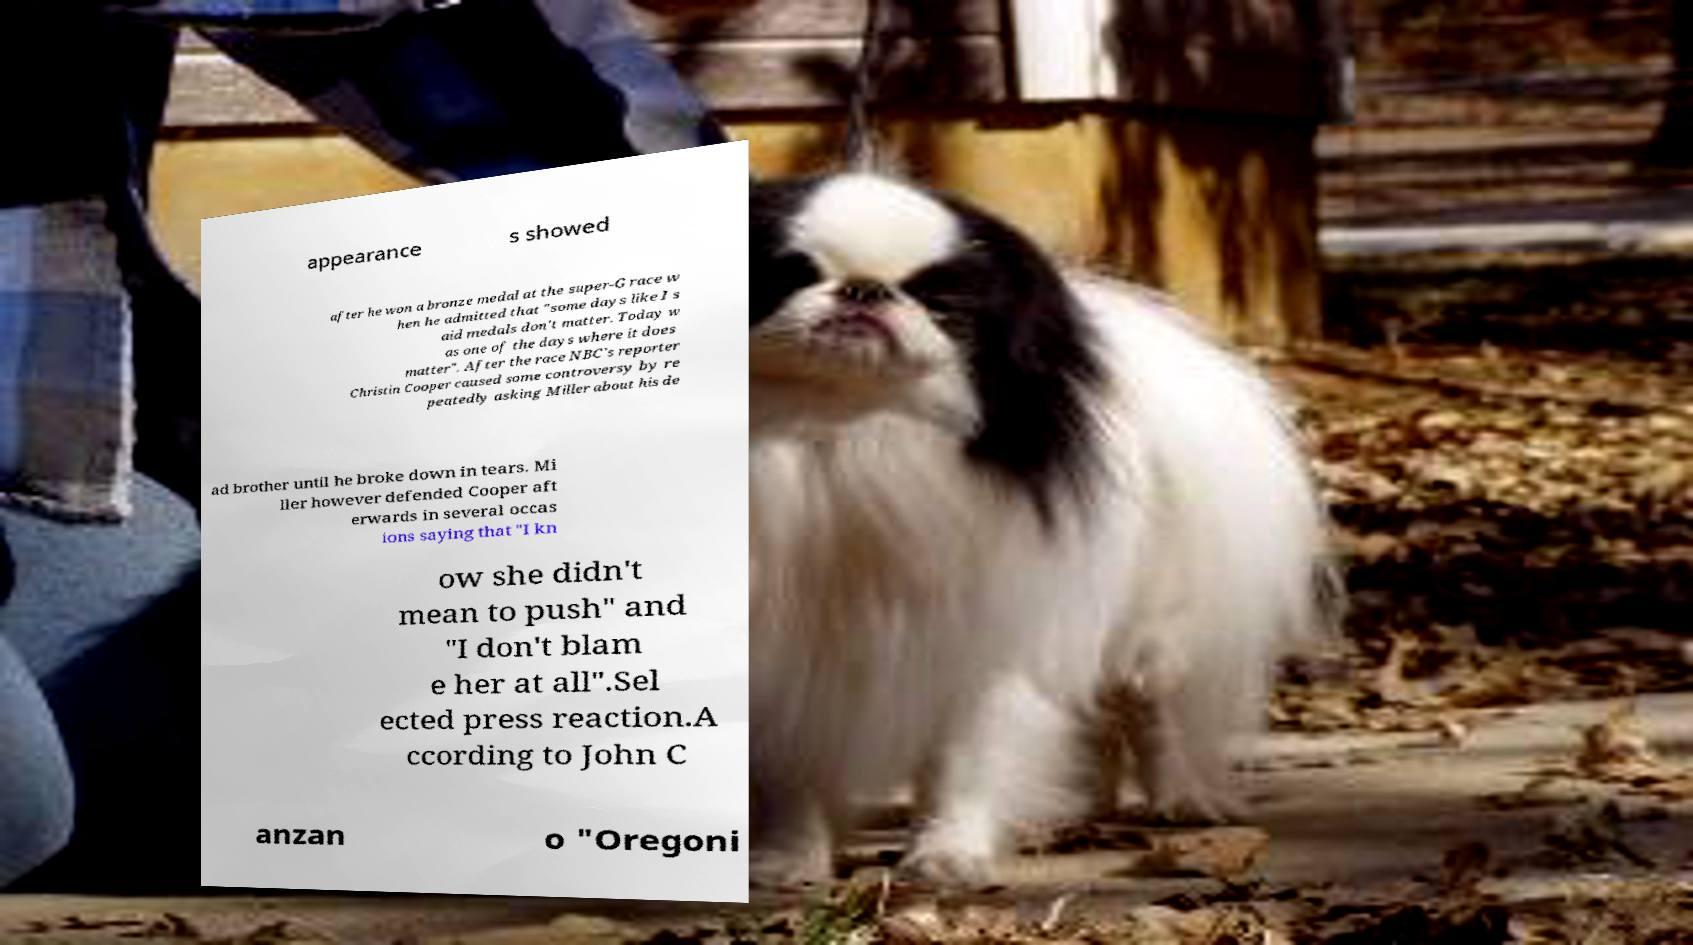Can you accurately transcribe the text from the provided image for me? appearance s showed after he won a bronze medal at the super-G race w hen he admitted that "some days like I s aid medals don't matter. Today w as one of the days where it does matter". After the race NBC's reporter Christin Cooper caused some controversy by re peatedly asking Miller about his de ad brother until he broke down in tears. Mi ller however defended Cooper aft erwards in several occas ions saying that "I kn ow she didn't mean to push" and "I don't blam e her at all".Sel ected press reaction.A ccording to John C anzan o "Oregoni 